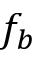Convert formula to latex. <formula><loc_0><loc_0><loc_500><loc_500>f _ { b }</formula> 